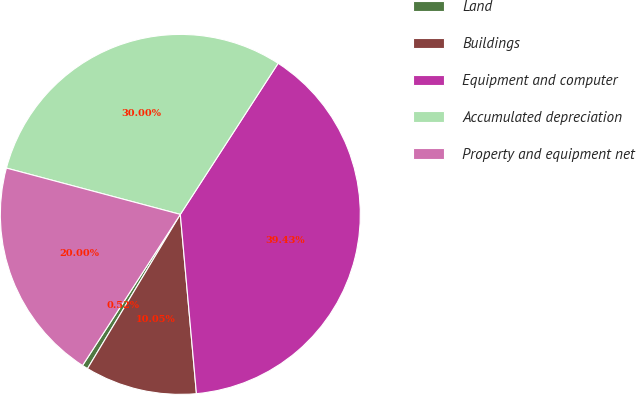Convert chart. <chart><loc_0><loc_0><loc_500><loc_500><pie_chart><fcel>Land<fcel>Buildings<fcel>Equipment and computer<fcel>Accumulated depreciation<fcel>Property and equipment net<nl><fcel>0.52%<fcel>10.05%<fcel>39.43%<fcel>30.0%<fcel>20.0%<nl></chart> 